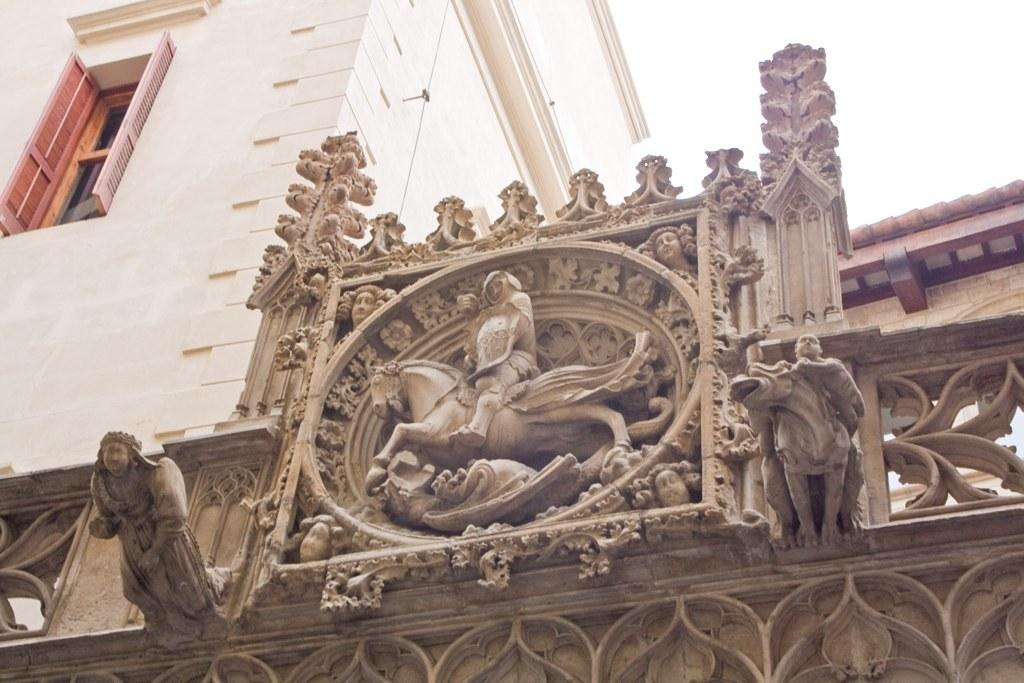What structure can be seen in the image? There is an arch in the image. What is on the arch? There are statues on the arch. What type of building can be seen in the background? There is a cream-colored building in the background. What is the color of the sky in the image? The sky appears to be white in color. What is the price of the robin perched on the arch in the image? There is no robin present in the image, so it is not possible to determine the price of one. 